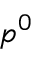Convert formula to latex. <formula><loc_0><loc_0><loc_500><loc_500>p ^ { 0 }</formula> 